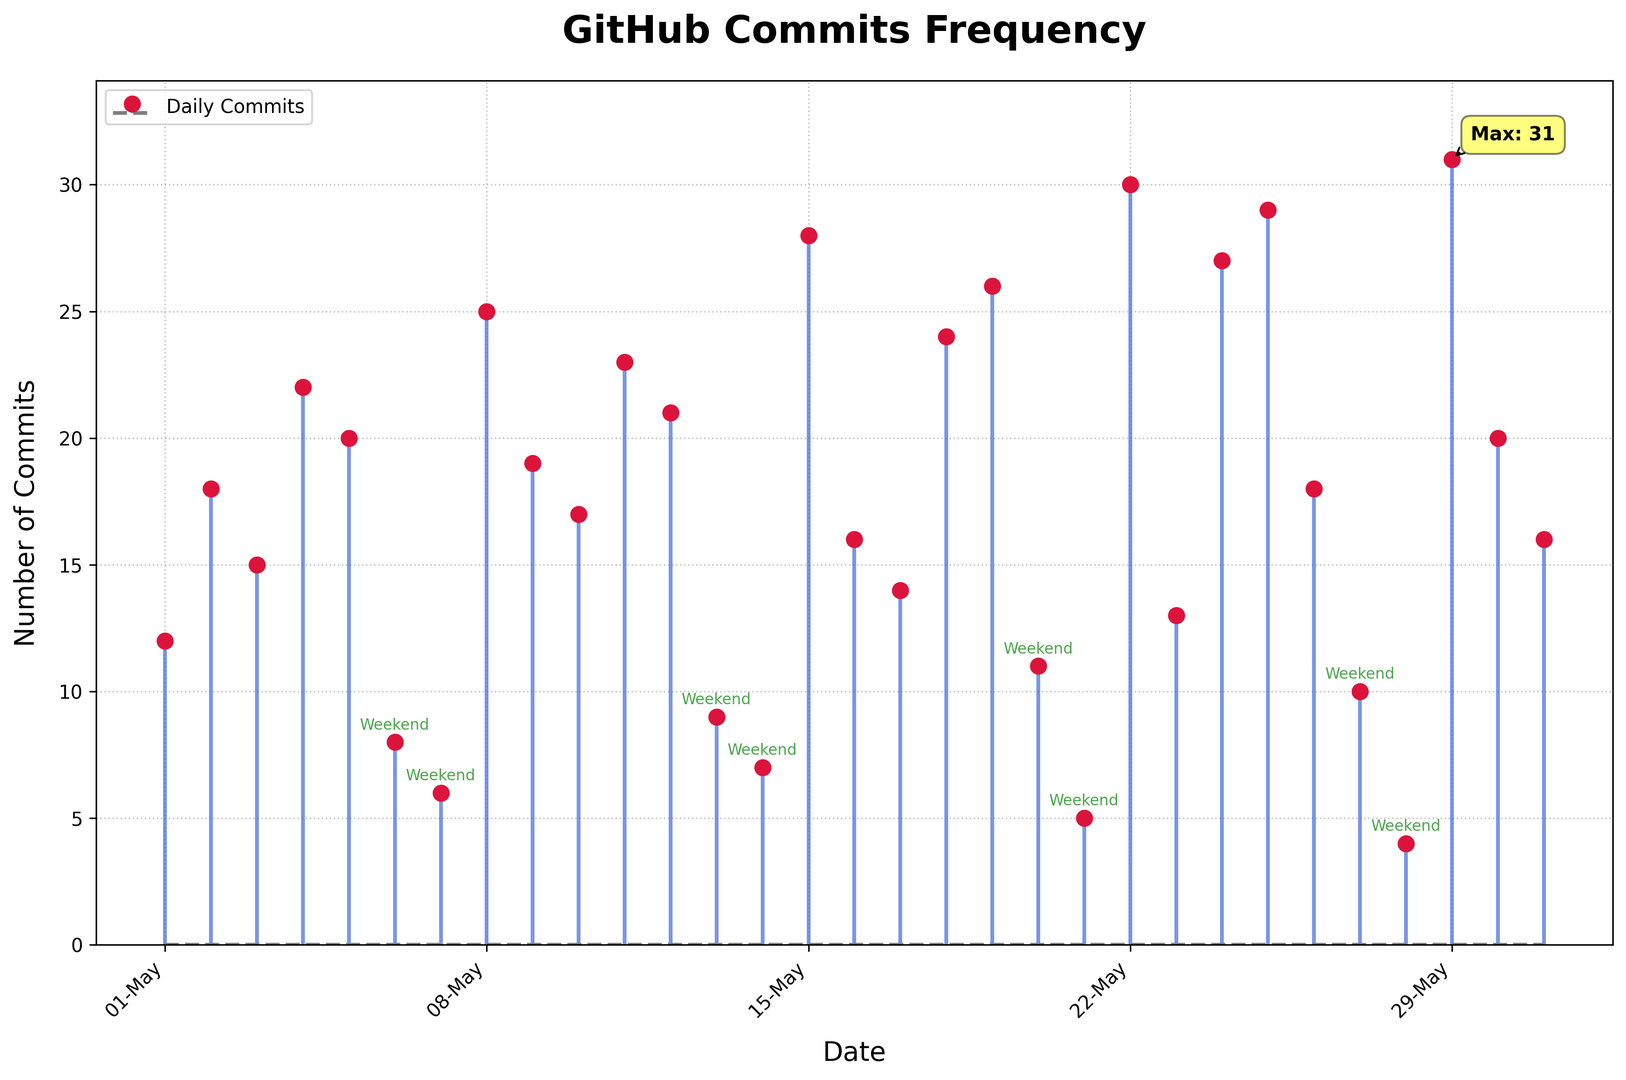What's the total number of commits made on weekends throughout the month? First, identify the weekend dates in the plot: May 6-7, 13-14, 20-21, and 27-28. Then, sum their commit numbers: 8+6+9+7+11+5+10+4 = 60.
Answer: 60 Which date had the highest number of commits, and how many commits were made on that day? The plot highlights the day with maximum commits using an annotation. From the annotation, the highest number of commits was 31 on May 29th.
Answer: May 29th, 31 commits How do the total commits made on weekdays compare to those on weekends? To find the total number of commits on weekdays: Sum commits from May 1-5, 8-12, 15-19, 22-26, and 29-31. Weekdays: 12+18+15+22+20+25+19+17+23+21+28+16+14+24+26+30+13+27+18+20+16 = 396. Weekends: 8+6+9+7+11+5+10+4 = 60. Compare 396 (weekdays) to 60 (weekends).
Answer: Weekdays: 396, Weekends: 60 On which dates were the number of commits less than 10, and what is the average number of commits for those dates? Identify dates with commits <10: May 6, 7, 13, 14, 20, 21, 27, 28. The respective numbers are 8, 6, 9, 7, 11, 5, 10, and 4. Add valid data points (<10): 8+6+9+7+5+4 = 39. Average = 39/6 ≈ 6.5.
Answer: May 6, 7, 13, 14, 21, 28. Average: 6.5 What's the trend in commits around the weekends throughout the month? Look at commit numbers for Friday, Saturday, Sunday, and Monday: E.g., May 5-8 (20, 8, 6, 25), May 12-15 (21, 9, 7, 28), etc. Generally, commits dip on weekends (Sat-Sun) and rise on weekdays (Mon).
Answer: Dip on weekends, rise on weekdays How did the number of commits on May 22 compare to those on May 19? Compare the commit numbers from the plot for May 22 and May 19. May 22 has 30 commits and May 19 has 26 commits.
Answer: May 22 has 4 more commits What's the median number of commits for this month, and how did you determine it? Sort commit counts, then find the middle value: Sorted = [4, 5, 6, 7, 8, 9, 10, 11, 12, 13, 14, 15, 16, 16, 17, 18, 18, 19, 20, 20, 21, 22, 23, 24, 25, 26, 27, 28, 29, 30, 31]. Median is middle value of 31 numbers = 18.
Answer: 18 